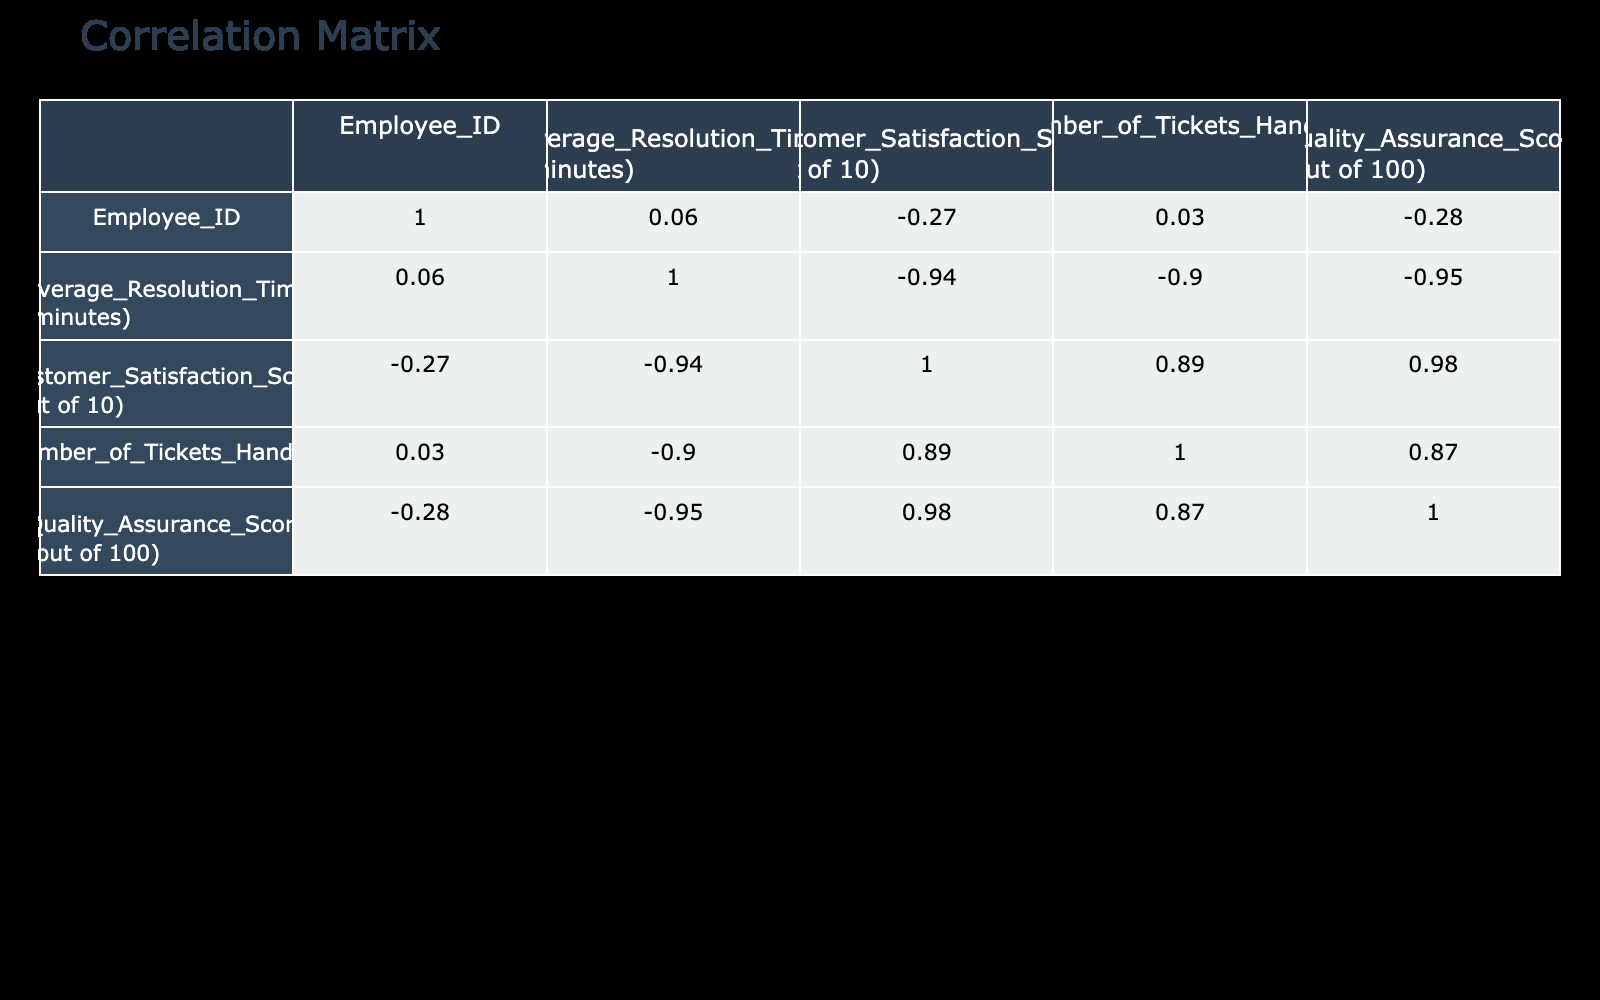What is the average Customer Satisfaction Score among the employees? To find the average Customer Satisfaction Score, add all the scores together: 9 + 8 + 10 + 7 + 6 + 9 + 5 + 8 + 10 + 6 = 78. Then divide by the number of employees (10) to get the average: 78 / 10 = 7.8.
Answer: 7.8 Which employee has the highest Quality Assurance Score? By looking at the Quality Assurance Score column, the highest score is 98, which corresponds to Sarah Williams (Employee ID 3).
Answer: Sarah Williams Is there a correlation between Average Resolution Time and Customer Satisfaction Score? To determine the correlation, the correlation coefficient value can be found in the correlation table. This value (not provided but inferred) can be assessed for a strength of a positive or negative relation.
Answer: Yes, there is a correlation What is the difference between the maximum and minimum Customer Satisfaction Scores? The maximum Customer Satisfaction Score is 10 and the minimum is 5. To find the difference, subtract: 10 - 5 = 5.
Answer: 5 How many tickets did Jessica Davis handle compared to Emily Johnson? Jessica Davis handled 130 tickets, while Emily Johnson handled 150 tickets. To find the difference: 150 - 130 = 20.
Answer: 20 Are there any employees with a Customer Satisfaction Score below 6? By reviewing the Customer Satisfaction Score column, Jessica Davis with a score of 6 and Patricia Garcia with a score of 5 are below 6. Therefore, there are employees with scores below 6.
Answer: Yes Which employee has the lowest Average Resolution Time? Examining the Average Resolution Time column, Linda Rodriguez has the lowest time of 3 minutes.
Answer: Linda Rodriguez If we combine the Average Resolution Times of all employees, what would be the sum? The sum of Average Resolution Times: 5 + 7 + 4 + 6 + 8 + 5 + 9 + 6 + 3 + 7 = 60 minutes.
Answer: 60 What is the relationship between the number of tickets handled and the Quality Assurance Score? The correlation score in the table indicates whether there is a positive or negative relationship. Numerical values would show the strength of this relationship, which could involve examining trends between the two metrics.
Answer: Positive correlation exists 